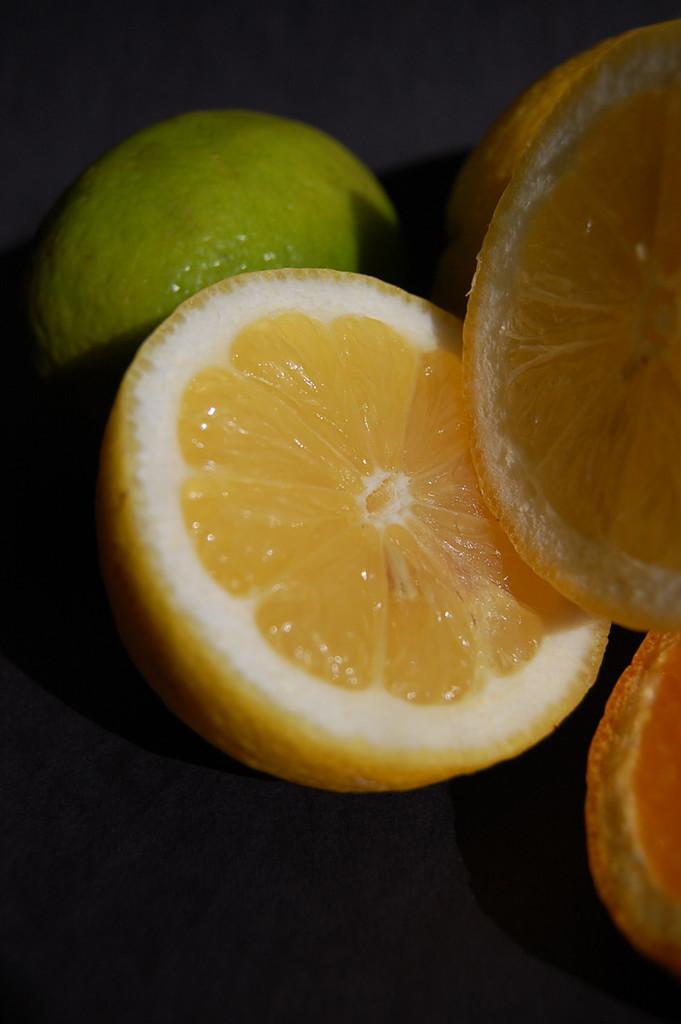What type of fruit can be seen in the image? There are orange slices and a green color fruit in the image. Can you describe the color of the orange slices? The orange slices have an orange color. What is the color of the other fruit in the image? The other fruit in the image has a green color. What type of leaf can be seen on the parent's plane in the image? There is no leaf, parent, or plane present in the image. 